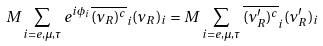<formula> <loc_0><loc_0><loc_500><loc_500>M \sum _ { i = e , \mu , \tau } e ^ { i \phi _ { i } } \overline { ( \nu _ { R } ) ^ { c } } _ { i } ( \nu _ { R } ) _ { i } = M \sum _ { i = e , \mu , \tau } \overline { ( \nu ^ { \prime } _ { R } ) ^ { c } } _ { i } ( \nu ^ { \prime } _ { R } ) _ { i }</formula> 